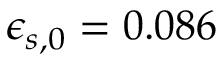<formula> <loc_0><loc_0><loc_500><loc_500>\epsilon _ { s , 0 } = 0 . 0 8 6</formula> 